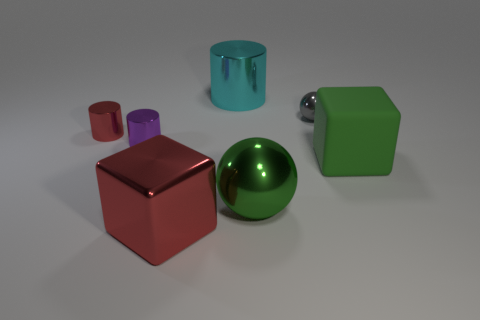What size is the other object that is the same color as the matte object?
Ensure brevity in your answer.  Large. Are there any tiny cylinders that have the same color as the large cylinder?
Provide a short and direct response. No. The purple object that is made of the same material as the large green sphere is what size?
Your response must be concise. Small. Are the small sphere and the tiny red thing made of the same material?
Keep it short and to the point. Yes. What is the color of the metal cylinder that is in front of the red thing behind the cube right of the big red cube?
Your response must be concise. Purple. What is the shape of the tiny gray thing?
Provide a succinct answer. Sphere. There is a matte cube; is its color the same as the large shiny thing that is right of the large cylinder?
Your response must be concise. Yes. Are there the same number of big cyan things left of the purple shiny cylinder and green shiny things?
Give a very brief answer. No. How many spheres have the same size as the purple object?
Ensure brevity in your answer.  1. The large rubber object that is the same color as the big sphere is what shape?
Keep it short and to the point. Cube. 